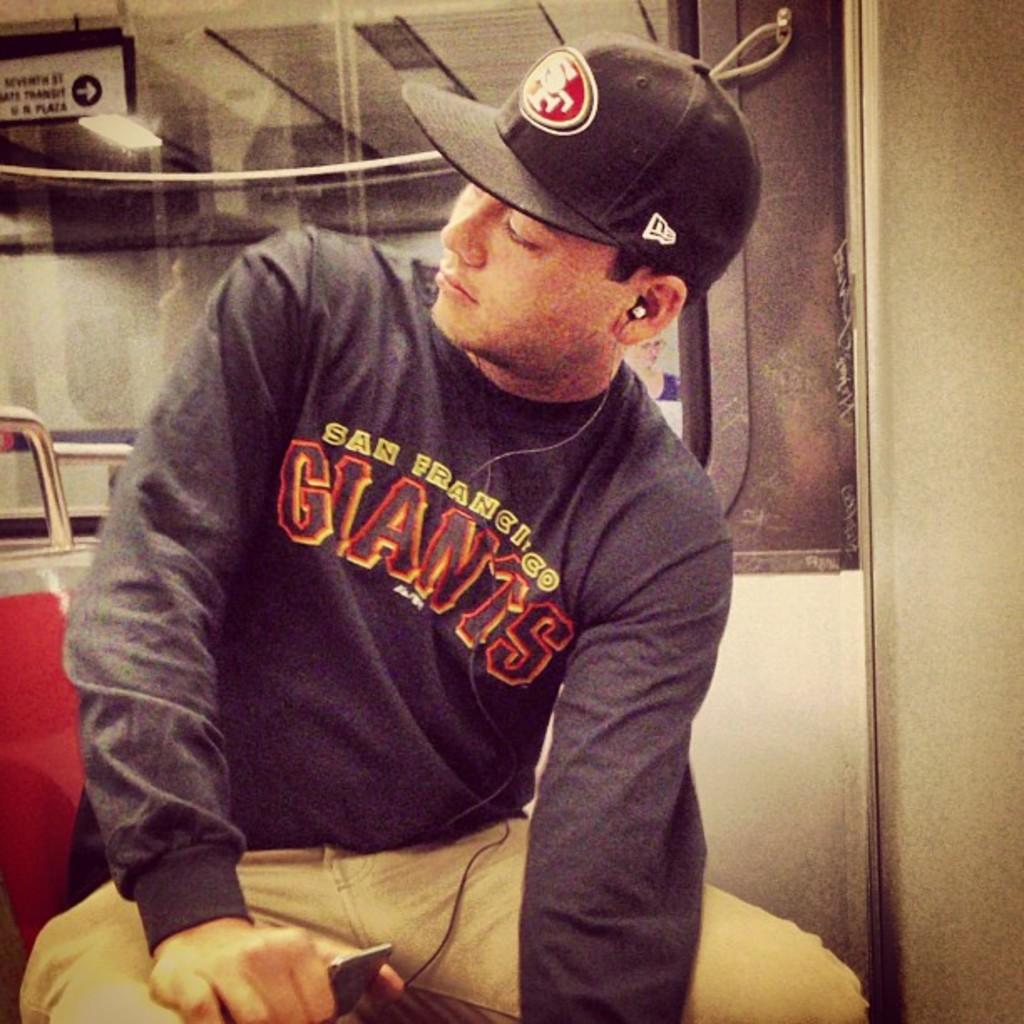What team is on the hat?
Offer a terse response. Sf. 